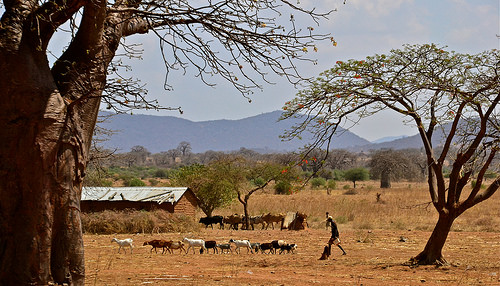<image>
Can you confirm if the goat is in the house? No. The goat is not contained within the house. These objects have a different spatial relationship. 